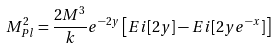<formula> <loc_0><loc_0><loc_500><loc_500>M _ { P l } ^ { 2 } = \frac { 2 M ^ { 3 } } { k } e ^ { - 2 y } \left [ E i [ 2 y ] - E i [ 2 y e ^ { - x } ] \right ]</formula> 